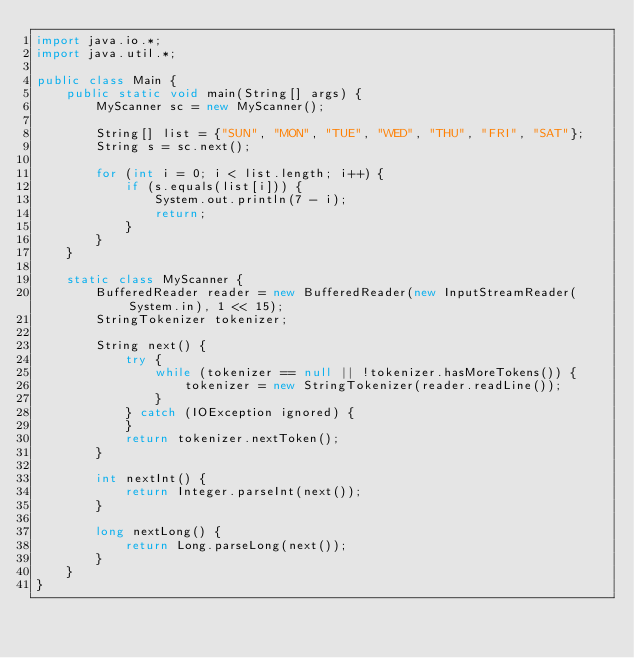Convert code to text. <code><loc_0><loc_0><loc_500><loc_500><_Java_>import java.io.*;
import java.util.*;

public class Main {
    public static void main(String[] args) {
        MyScanner sc = new MyScanner();

        String[] list = {"SUN", "MON", "TUE", "WED", "THU", "FRI", "SAT"};
        String s = sc.next();

        for (int i = 0; i < list.length; i++) {
            if (s.equals(list[i])) {
                System.out.println(7 - i);
                return;
            }
        }
    }

    static class MyScanner {
        BufferedReader reader = new BufferedReader(new InputStreamReader(System.in), 1 << 15);
        StringTokenizer tokenizer;

        String next() {
            try {
                while (tokenizer == null || !tokenizer.hasMoreTokens()) {
                    tokenizer = new StringTokenizer(reader.readLine());
                }
            } catch (IOException ignored) {
            }
            return tokenizer.nextToken();
        }

        int nextInt() {
            return Integer.parseInt(next());
        }

        long nextLong() {
            return Long.parseLong(next());
        }
    }
}</code> 